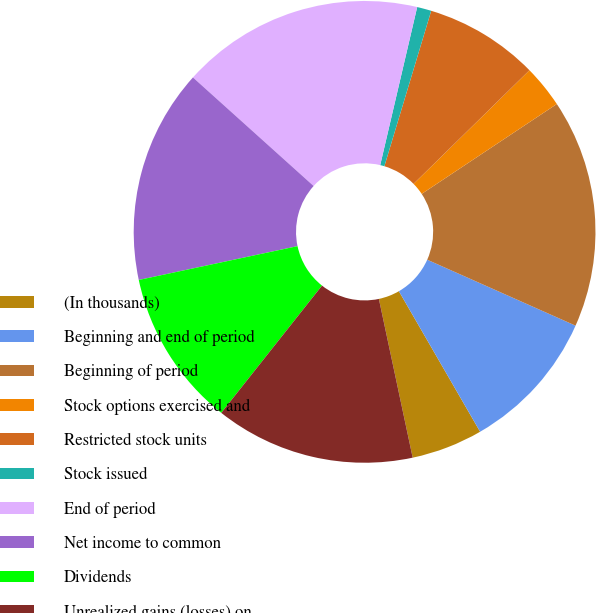Convert chart to OTSL. <chart><loc_0><loc_0><loc_500><loc_500><pie_chart><fcel>(In thousands)<fcel>Beginning and end of period<fcel>Beginning of period<fcel>Stock options exercised and<fcel>Restricted stock units<fcel>Stock issued<fcel>End of period<fcel>Net income to common<fcel>Dividends<fcel>Unrealized gains (losses) on<nl><fcel>5.0%<fcel>10.0%<fcel>16.0%<fcel>3.0%<fcel>8.0%<fcel>1.0%<fcel>17.0%<fcel>15.0%<fcel>11.0%<fcel>14.0%<nl></chart> 